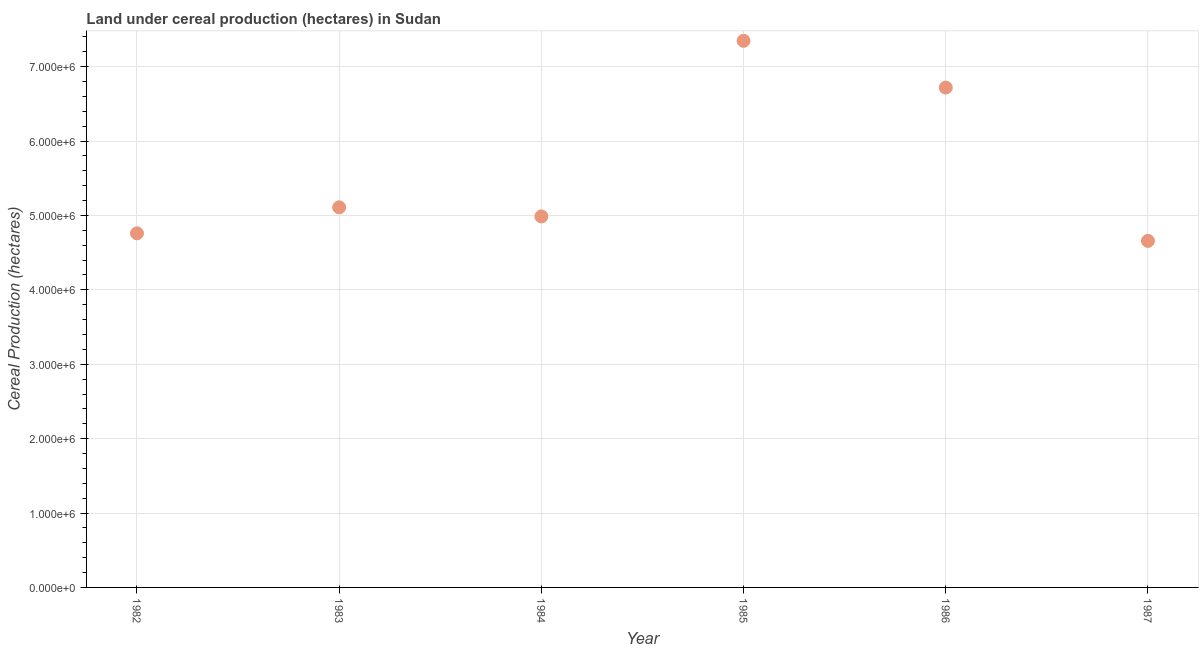What is the land under cereal production in 1985?
Your answer should be compact. 7.35e+06. Across all years, what is the maximum land under cereal production?
Offer a very short reply. 7.35e+06. Across all years, what is the minimum land under cereal production?
Give a very brief answer. 4.66e+06. What is the sum of the land under cereal production?
Provide a succinct answer. 3.36e+07. What is the difference between the land under cereal production in 1984 and 1987?
Provide a short and direct response. 3.29e+05. What is the average land under cereal production per year?
Make the answer very short. 5.60e+06. What is the median land under cereal production?
Offer a terse response. 5.05e+06. In how many years, is the land under cereal production greater than 1800000 hectares?
Your answer should be compact. 6. What is the ratio of the land under cereal production in 1983 to that in 1987?
Keep it short and to the point. 1.1. Is the land under cereal production in 1985 less than that in 1986?
Give a very brief answer. No. What is the difference between the highest and the second highest land under cereal production?
Keep it short and to the point. 6.28e+05. What is the difference between the highest and the lowest land under cereal production?
Ensure brevity in your answer.  2.69e+06. Does the land under cereal production monotonically increase over the years?
Provide a short and direct response. No. How many dotlines are there?
Your answer should be compact. 1. How many years are there in the graph?
Your response must be concise. 6. Are the values on the major ticks of Y-axis written in scientific E-notation?
Give a very brief answer. Yes. Does the graph contain any zero values?
Keep it short and to the point. No. Does the graph contain grids?
Give a very brief answer. Yes. What is the title of the graph?
Provide a short and direct response. Land under cereal production (hectares) in Sudan. What is the label or title of the X-axis?
Your answer should be compact. Year. What is the label or title of the Y-axis?
Give a very brief answer. Cereal Production (hectares). What is the Cereal Production (hectares) in 1982?
Provide a succinct answer. 4.76e+06. What is the Cereal Production (hectares) in 1983?
Your response must be concise. 5.11e+06. What is the Cereal Production (hectares) in 1984?
Provide a short and direct response. 4.99e+06. What is the Cereal Production (hectares) in 1985?
Provide a short and direct response. 7.35e+06. What is the Cereal Production (hectares) in 1986?
Offer a terse response. 6.72e+06. What is the Cereal Production (hectares) in 1987?
Offer a very short reply. 4.66e+06. What is the difference between the Cereal Production (hectares) in 1982 and 1983?
Provide a succinct answer. -3.49e+05. What is the difference between the Cereal Production (hectares) in 1982 and 1984?
Your answer should be compact. -2.27e+05. What is the difference between the Cereal Production (hectares) in 1982 and 1985?
Your answer should be very brief. -2.59e+06. What is the difference between the Cereal Production (hectares) in 1982 and 1986?
Give a very brief answer. -1.96e+06. What is the difference between the Cereal Production (hectares) in 1982 and 1987?
Your response must be concise. 1.01e+05. What is the difference between the Cereal Production (hectares) in 1983 and 1984?
Ensure brevity in your answer.  1.22e+05. What is the difference between the Cereal Production (hectares) in 1983 and 1985?
Provide a short and direct response. -2.24e+06. What is the difference between the Cereal Production (hectares) in 1983 and 1986?
Your answer should be very brief. -1.61e+06. What is the difference between the Cereal Production (hectares) in 1983 and 1987?
Your response must be concise. 4.51e+05. What is the difference between the Cereal Production (hectares) in 1984 and 1985?
Offer a terse response. -2.36e+06. What is the difference between the Cereal Production (hectares) in 1984 and 1986?
Your answer should be very brief. -1.73e+06. What is the difference between the Cereal Production (hectares) in 1984 and 1987?
Provide a short and direct response. 3.29e+05. What is the difference between the Cereal Production (hectares) in 1985 and 1986?
Provide a succinct answer. 6.28e+05. What is the difference between the Cereal Production (hectares) in 1985 and 1987?
Offer a terse response. 2.69e+06. What is the difference between the Cereal Production (hectares) in 1986 and 1987?
Offer a terse response. 2.06e+06. What is the ratio of the Cereal Production (hectares) in 1982 to that in 1983?
Keep it short and to the point. 0.93. What is the ratio of the Cereal Production (hectares) in 1982 to that in 1984?
Provide a short and direct response. 0.95. What is the ratio of the Cereal Production (hectares) in 1982 to that in 1985?
Make the answer very short. 0.65. What is the ratio of the Cereal Production (hectares) in 1982 to that in 1986?
Keep it short and to the point. 0.71. What is the ratio of the Cereal Production (hectares) in 1983 to that in 1985?
Provide a short and direct response. 0.69. What is the ratio of the Cereal Production (hectares) in 1983 to that in 1986?
Offer a very short reply. 0.76. What is the ratio of the Cereal Production (hectares) in 1983 to that in 1987?
Keep it short and to the point. 1.1. What is the ratio of the Cereal Production (hectares) in 1984 to that in 1985?
Your answer should be very brief. 0.68. What is the ratio of the Cereal Production (hectares) in 1984 to that in 1986?
Keep it short and to the point. 0.74. What is the ratio of the Cereal Production (hectares) in 1984 to that in 1987?
Make the answer very short. 1.07. What is the ratio of the Cereal Production (hectares) in 1985 to that in 1986?
Give a very brief answer. 1.09. What is the ratio of the Cereal Production (hectares) in 1985 to that in 1987?
Give a very brief answer. 1.58. What is the ratio of the Cereal Production (hectares) in 1986 to that in 1987?
Offer a terse response. 1.44. 